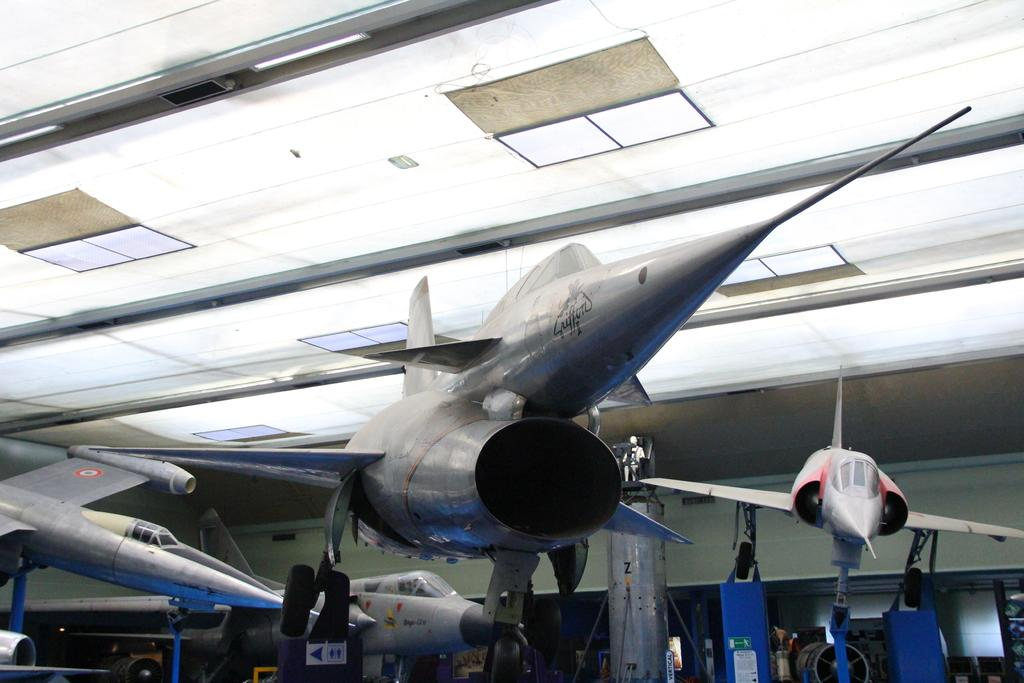What is the main subject of the image? The main subject of the image is aircrafts. What can be seen in the background of the image? There is a wall in the background of the image. What is visible at the top of the image? There is a roof visible at the top of the image. How many pairs of shoes are visible in the image? There are no shoes present in the image. What type of toad can be seen sitting on the aircraft in the image? There is no toad present in the image; it features only aircrafts. 